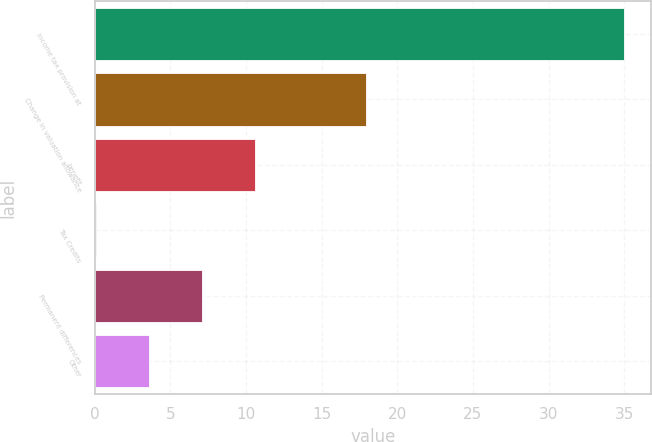Convert chart to OTSL. <chart><loc_0><loc_0><loc_500><loc_500><bar_chart><fcel>Income tax provision at<fcel>Change in valuation allowance<fcel>benefit<fcel>Tax Credits<fcel>Permanent differences<fcel>Other<nl><fcel>35<fcel>17.9<fcel>10.57<fcel>0.1<fcel>7.08<fcel>3.59<nl></chart> 